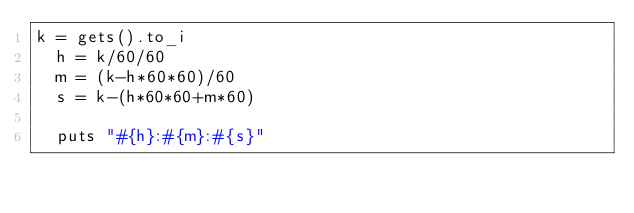Convert code to text. <code><loc_0><loc_0><loc_500><loc_500><_Ruby_>k = gets().to_i
  h = k/60/60
  m = (k-h*60*60)/60
  s = k-(h*60*60+m*60)

  puts "#{h}:#{m}:#{s}"
</code> 